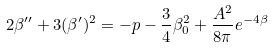Convert formula to latex. <formula><loc_0><loc_0><loc_500><loc_500>2 \beta ^ { \prime \prime } + 3 ( \beta ^ { \prime } ) ^ { 2 } = - p - \frac { 3 } { 4 } \beta _ { 0 } ^ { 2 } + \frac { A ^ { 2 } } { 8 \pi } e ^ { - 4 \beta }</formula> 